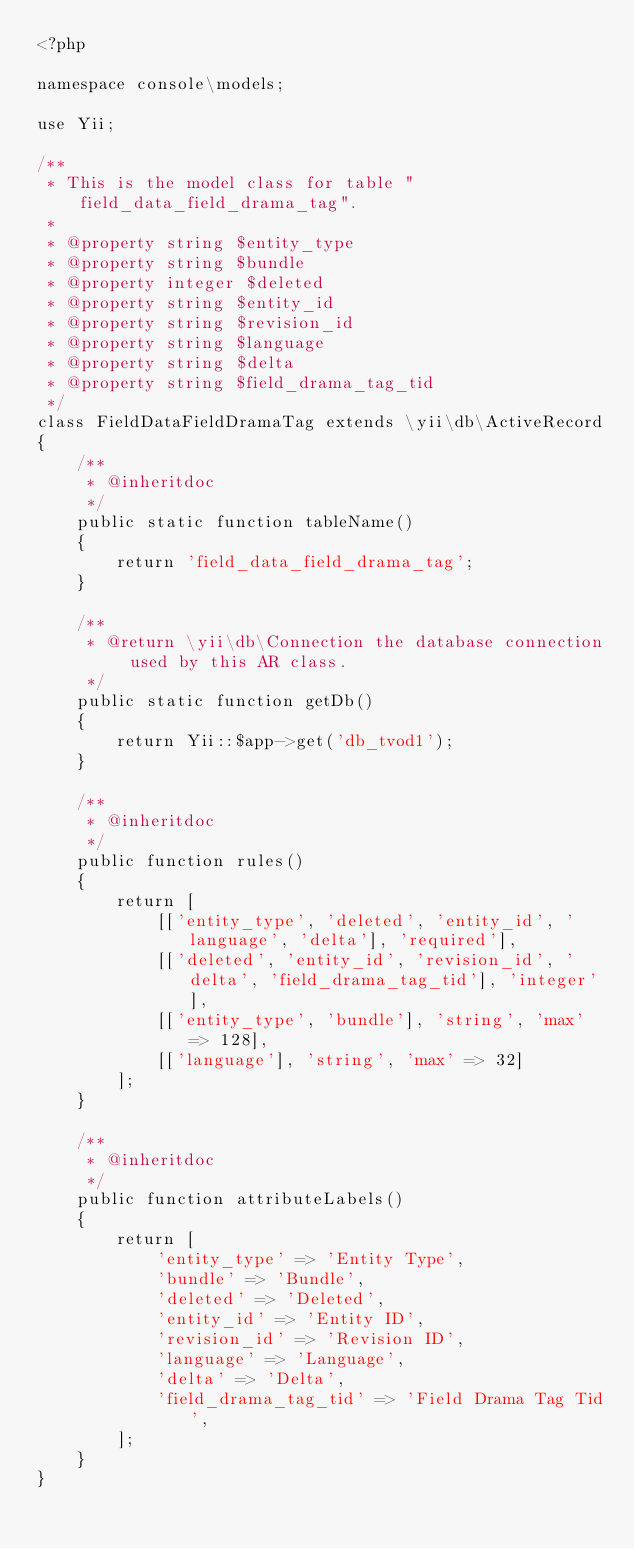<code> <loc_0><loc_0><loc_500><loc_500><_PHP_><?php

namespace console\models;

use Yii;

/**
 * This is the model class for table "field_data_field_drama_tag".
 *
 * @property string $entity_type
 * @property string $bundle
 * @property integer $deleted
 * @property string $entity_id
 * @property string $revision_id
 * @property string $language
 * @property string $delta
 * @property string $field_drama_tag_tid
 */
class FieldDataFieldDramaTag extends \yii\db\ActiveRecord
{
    /**
     * @inheritdoc
     */
    public static function tableName()
    {
        return 'field_data_field_drama_tag';
    }

    /**
     * @return \yii\db\Connection the database connection used by this AR class.
     */
    public static function getDb()
    {
        return Yii::$app->get('db_tvod1');
    }

    /**
     * @inheritdoc
     */
    public function rules()
    {
        return [
            [['entity_type', 'deleted', 'entity_id', 'language', 'delta'], 'required'],
            [['deleted', 'entity_id', 'revision_id', 'delta', 'field_drama_tag_tid'], 'integer'],
            [['entity_type', 'bundle'], 'string', 'max' => 128],
            [['language'], 'string', 'max' => 32]
        ];
    }

    /**
     * @inheritdoc
     */
    public function attributeLabels()
    {
        return [
            'entity_type' => 'Entity Type',
            'bundle' => 'Bundle',
            'deleted' => 'Deleted',
            'entity_id' => 'Entity ID',
            'revision_id' => 'Revision ID',
            'language' => 'Language',
            'delta' => 'Delta',
            'field_drama_tag_tid' => 'Field Drama Tag Tid',
        ];
    }
}
</code> 